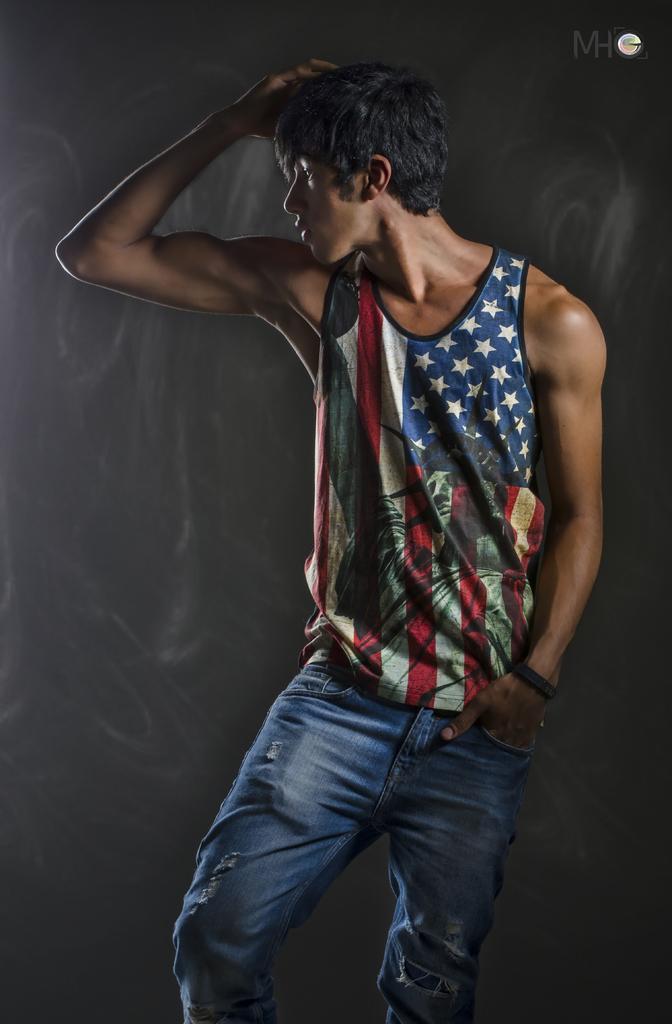In one or two sentences, can you explain what this image depicts? In this picture we can see a boy wearing american pattern half sleeves t-shirt and jean standing and giving a pose into the camera. 